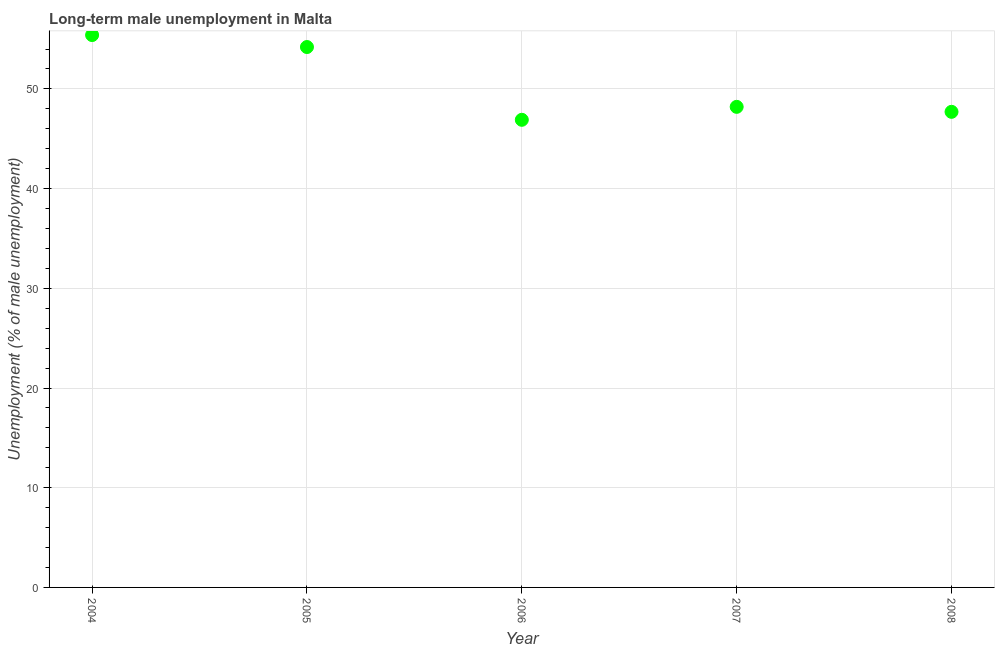What is the long-term male unemployment in 2008?
Make the answer very short. 47.7. Across all years, what is the maximum long-term male unemployment?
Give a very brief answer. 55.4. Across all years, what is the minimum long-term male unemployment?
Offer a very short reply. 46.9. What is the sum of the long-term male unemployment?
Your answer should be compact. 252.4. What is the difference between the long-term male unemployment in 2005 and 2008?
Your answer should be compact. 6.5. What is the average long-term male unemployment per year?
Keep it short and to the point. 50.48. What is the median long-term male unemployment?
Give a very brief answer. 48.2. In how many years, is the long-term male unemployment greater than 16 %?
Provide a succinct answer. 5. What is the ratio of the long-term male unemployment in 2005 to that in 2007?
Your answer should be compact. 1.12. What is the difference between the highest and the second highest long-term male unemployment?
Provide a short and direct response. 1.2. Is the sum of the long-term male unemployment in 2005 and 2007 greater than the maximum long-term male unemployment across all years?
Provide a succinct answer. Yes. In how many years, is the long-term male unemployment greater than the average long-term male unemployment taken over all years?
Provide a succinct answer. 2. What is the title of the graph?
Provide a short and direct response. Long-term male unemployment in Malta. What is the label or title of the X-axis?
Ensure brevity in your answer.  Year. What is the label or title of the Y-axis?
Your answer should be compact. Unemployment (% of male unemployment). What is the Unemployment (% of male unemployment) in 2004?
Ensure brevity in your answer.  55.4. What is the Unemployment (% of male unemployment) in 2005?
Your answer should be very brief. 54.2. What is the Unemployment (% of male unemployment) in 2006?
Make the answer very short. 46.9. What is the Unemployment (% of male unemployment) in 2007?
Provide a succinct answer. 48.2. What is the Unemployment (% of male unemployment) in 2008?
Give a very brief answer. 47.7. What is the difference between the Unemployment (% of male unemployment) in 2004 and 2008?
Give a very brief answer. 7.7. What is the difference between the Unemployment (% of male unemployment) in 2005 and 2006?
Make the answer very short. 7.3. What is the difference between the Unemployment (% of male unemployment) in 2005 and 2008?
Give a very brief answer. 6.5. What is the difference between the Unemployment (% of male unemployment) in 2006 and 2007?
Make the answer very short. -1.3. What is the ratio of the Unemployment (% of male unemployment) in 2004 to that in 2006?
Your answer should be very brief. 1.18. What is the ratio of the Unemployment (% of male unemployment) in 2004 to that in 2007?
Ensure brevity in your answer.  1.15. What is the ratio of the Unemployment (% of male unemployment) in 2004 to that in 2008?
Your response must be concise. 1.16. What is the ratio of the Unemployment (% of male unemployment) in 2005 to that in 2006?
Ensure brevity in your answer.  1.16. What is the ratio of the Unemployment (% of male unemployment) in 2005 to that in 2007?
Your answer should be very brief. 1.12. What is the ratio of the Unemployment (% of male unemployment) in 2005 to that in 2008?
Offer a very short reply. 1.14. What is the ratio of the Unemployment (% of male unemployment) in 2006 to that in 2007?
Ensure brevity in your answer.  0.97. What is the ratio of the Unemployment (% of male unemployment) in 2006 to that in 2008?
Ensure brevity in your answer.  0.98. 